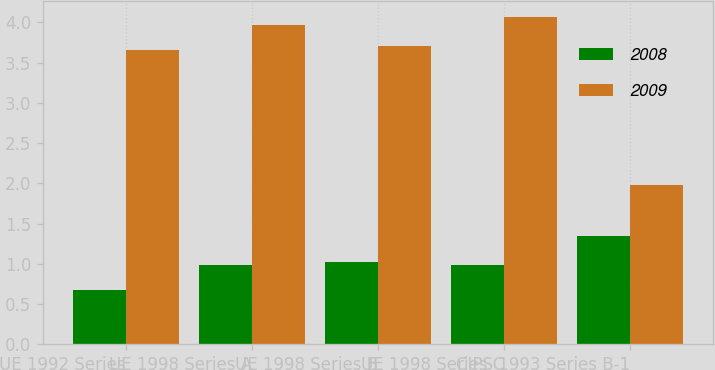Convert chart. <chart><loc_0><loc_0><loc_500><loc_500><stacked_bar_chart><ecel><fcel>UE 1992 Series<fcel>UE 1998 Series A<fcel>UE 1998 Series B<fcel>UE 1998 Series C<fcel>CIPS 1993 Series B-1<nl><fcel>2008<fcel>0.68<fcel>0.99<fcel>1.02<fcel>0.99<fcel>1.34<nl><fcel>2009<fcel>3.66<fcel>3.97<fcel>3.71<fcel>4.06<fcel>1.98<nl></chart> 